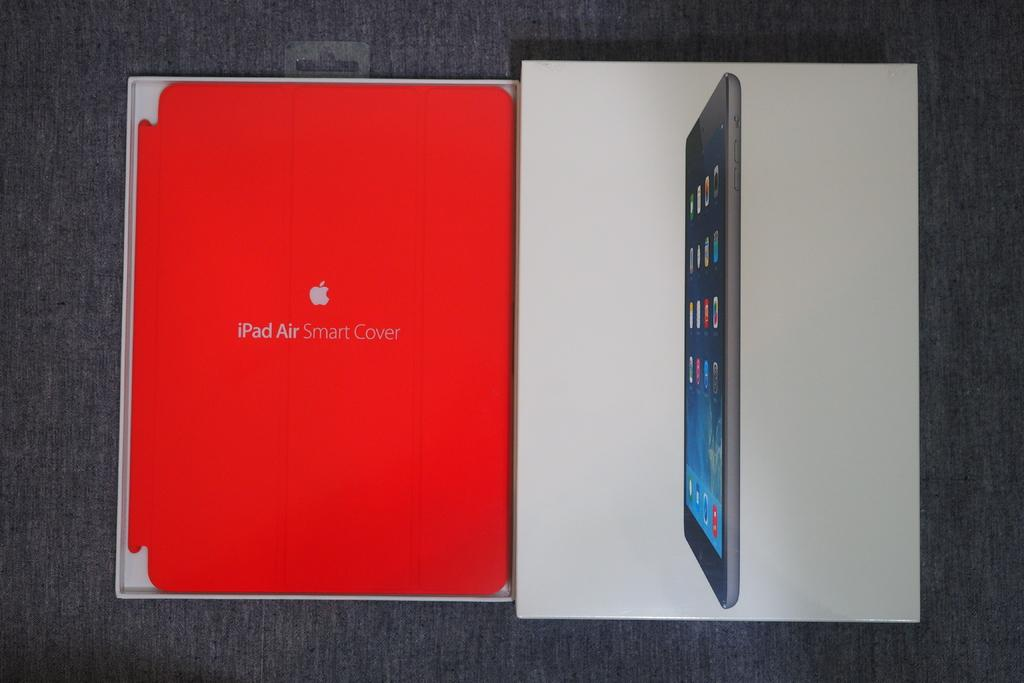Provide a one-sentence caption for the provided image. The box of an iPad Air is opened on a gray surface. 